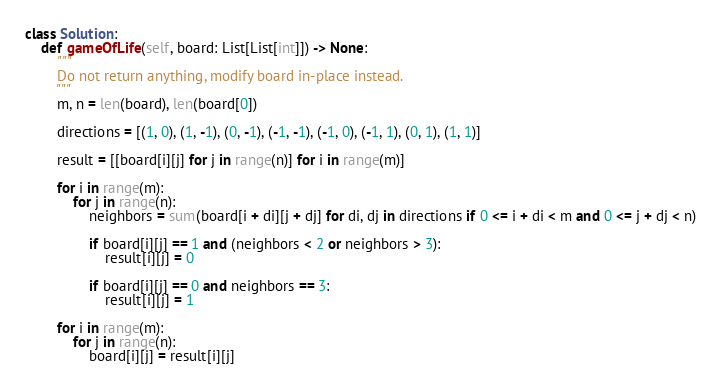Convert code to text. <code><loc_0><loc_0><loc_500><loc_500><_Python_>class Solution:
    def gameOfLife(self, board: List[List[int]]) -> None:
        """
        Do not return anything, modify board in-place instead.
        """
        m, n = len(board), len(board[0])

        directions = [(1, 0), (1, -1), (0, -1), (-1, -1), (-1, 0), (-1, 1), (0, 1), (1, 1)]

        result = [[board[i][j] for j in range(n)] for i in range(m)]

        for i in range(m):
            for j in range(n):
                neighbors = sum(board[i + di][j + dj] for di, dj in directions if 0 <= i + di < m and 0 <= j + dj < n)

                if board[i][j] == 1 and (neighbors < 2 or neighbors > 3):
                    result[i][j] = 0

                if board[i][j] == 0 and neighbors == 3:
                    result[i][j] = 1

        for i in range(m):
            for j in range(n):
                board[i][j] = result[i][j]
</code> 